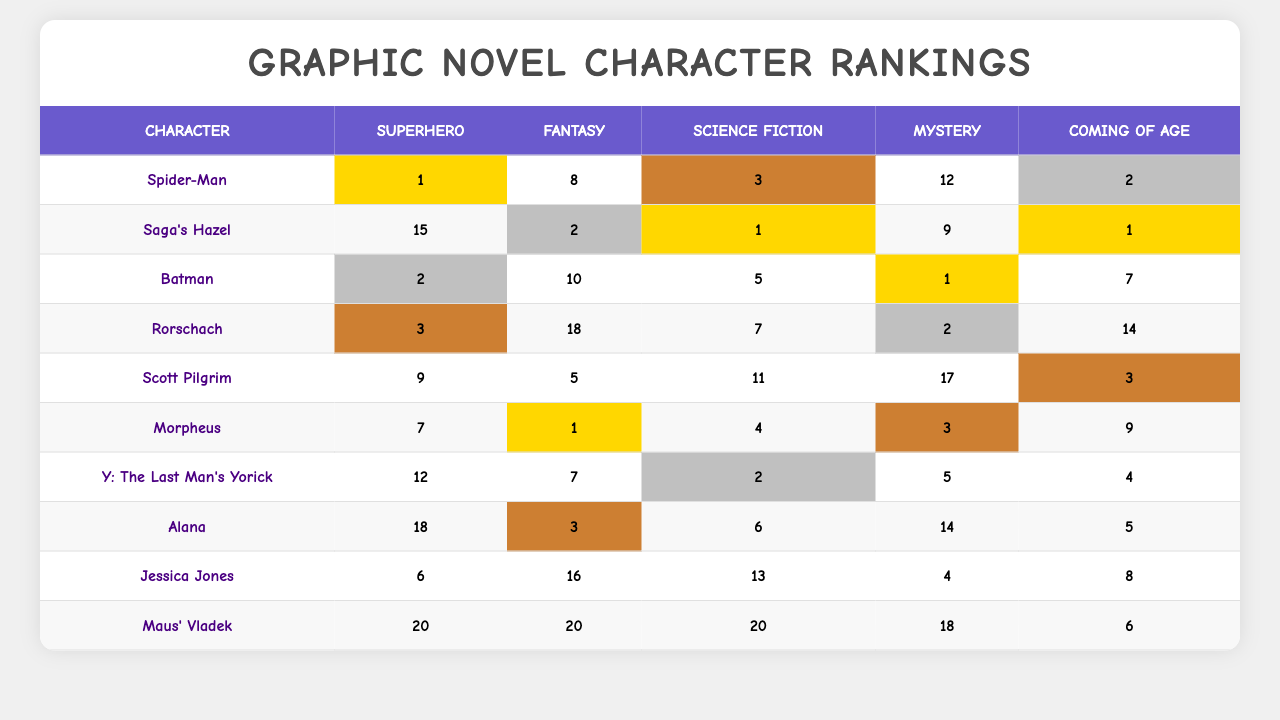What is the highest-ranking character in the Superhero genre? Looking at the Superhero column, the lowest rank (1) is held by Spider-Man.
Answer: Spider-Man Which character has the lowest rank in the Mystery genre? The lowest rank in the Mystery column is 1, which belongs to Batman.
Answer: Batman Who is ranked 2nd in the Coming of Age genre? Checking the Coming of Age column, the character ranked 2nd is Spider-Man.
Answer: Spider-Man What is the average rank of characters in the Fantasy genre? The ranks in the Fantasy genre are 8, 2, 10, 18, 5, 1, 7, 3, 16, and 20, totaling 90. There are 10 characters, so the average is 90 divided by 10, which equals 9.
Answer: 9 Does Rorschach have a higher rank in Science Fiction than in Coming of Age? In Science Fiction, Rorschach's rank is 7, and in Coming of Age, it is 14. Since 7 is less than 14, Rorschach does not have a higher rank in Science Fiction.
Answer: No Which character consistently ranks in the bottom three in all genres? Checking the ranks for each character, Maus' Vladek ranks last in Superhero, Fantasy, Science Fiction, and ranks 18th in Mystery, and is 6th in Coming of Age. Therefore, it ends up being consistently low across the first four genres.
Answer: Maus' Vladek Which character has the highest combined total of ranks across all genres? Adding up the ranks for each character: Spider-Man (1+8+3+12+2=26), Saga's Hazel (15+2+1+9+1=28), Batman (2+10+5+1+7=25), Rorschach (3+18+7+2+14=44), Scott Pilgrim (9+5+11+17+3=45), Morpheus (7+1+4+3+9=24), Y: The Last Man's Yorick (12+7+2+5+4=30), Alana (18+3+6+14+5=46), Jessica Jones (6+16+13+4+8=47), and Maus' Vladek (20+20+20+18+6=84). Maus' Vladek has the highest total rank of 84.
Answer: Maus' Vladek Which genre has the most characters ranked within the top 3? The Superhero genre has Spider-Man (1), Batman (2), and Rorschach (3), totaling 3 characters. Checking the other genres shows fewer than 3 characters in the top ranks.
Answer: Superhero If you rank the characters based on their highest rank in any genre, who would be ranked 3rd? Ranking based on the highest position in all genres: Spider-Man (1, Superhero), Batman (1, Mystery), Rorschach (2, Superhero), Scott Pilgrim (3, Superhero), Y: The Last Man's Yorick (2, Coming of Age) and so on, thus the third highest rank would go to Rorschach.
Answer: Rorschach 